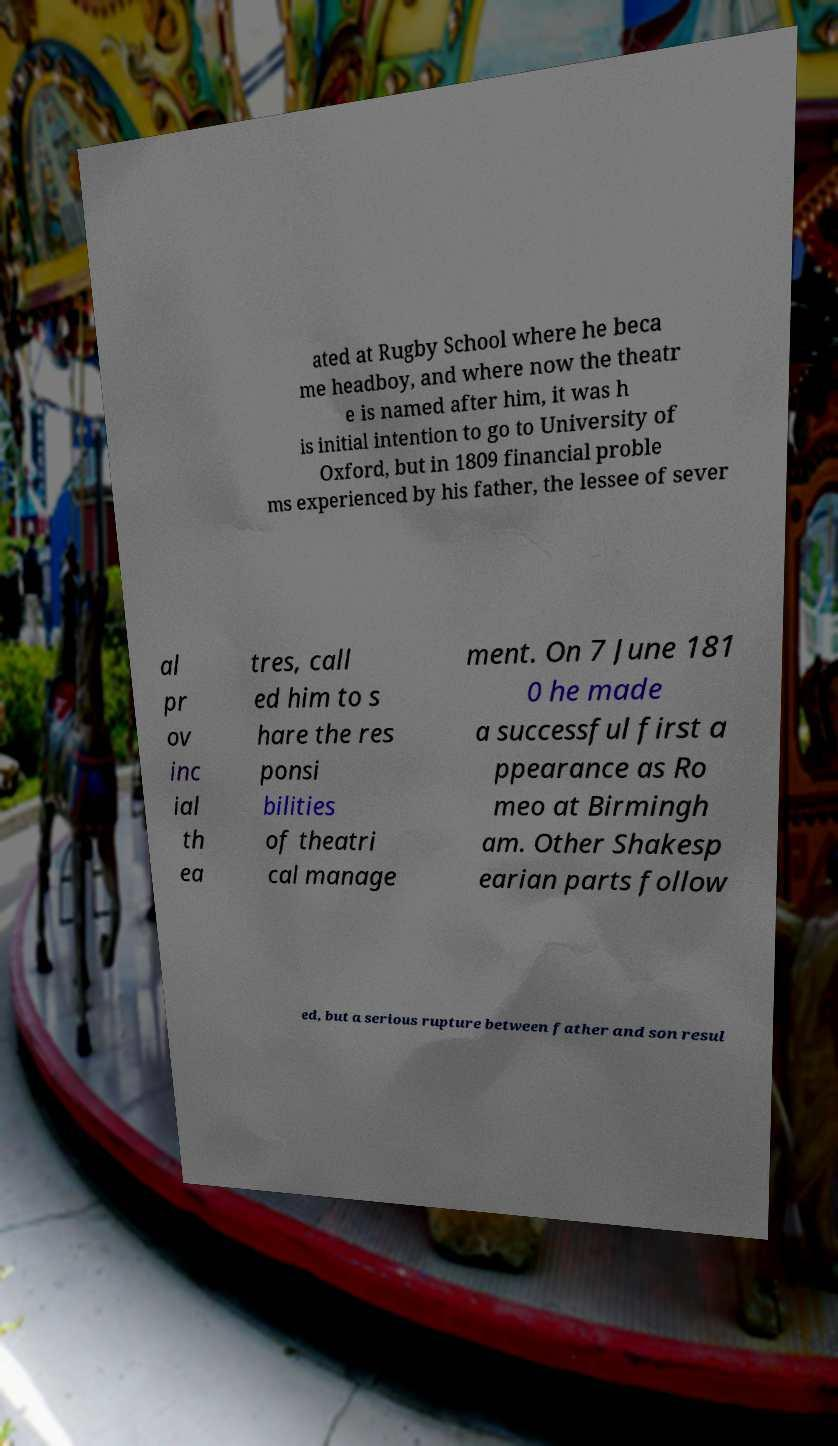Could you assist in decoding the text presented in this image and type it out clearly? ated at Rugby School where he beca me headboy, and where now the theatr e is named after him, it was h is initial intention to go to University of Oxford, but in 1809 financial proble ms experienced by his father, the lessee of sever al pr ov inc ial th ea tres, call ed him to s hare the res ponsi bilities of theatri cal manage ment. On 7 June 181 0 he made a successful first a ppearance as Ro meo at Birmingh am. Other Shakesp earian parts follow ed, but a serious rupture between father and son resul 